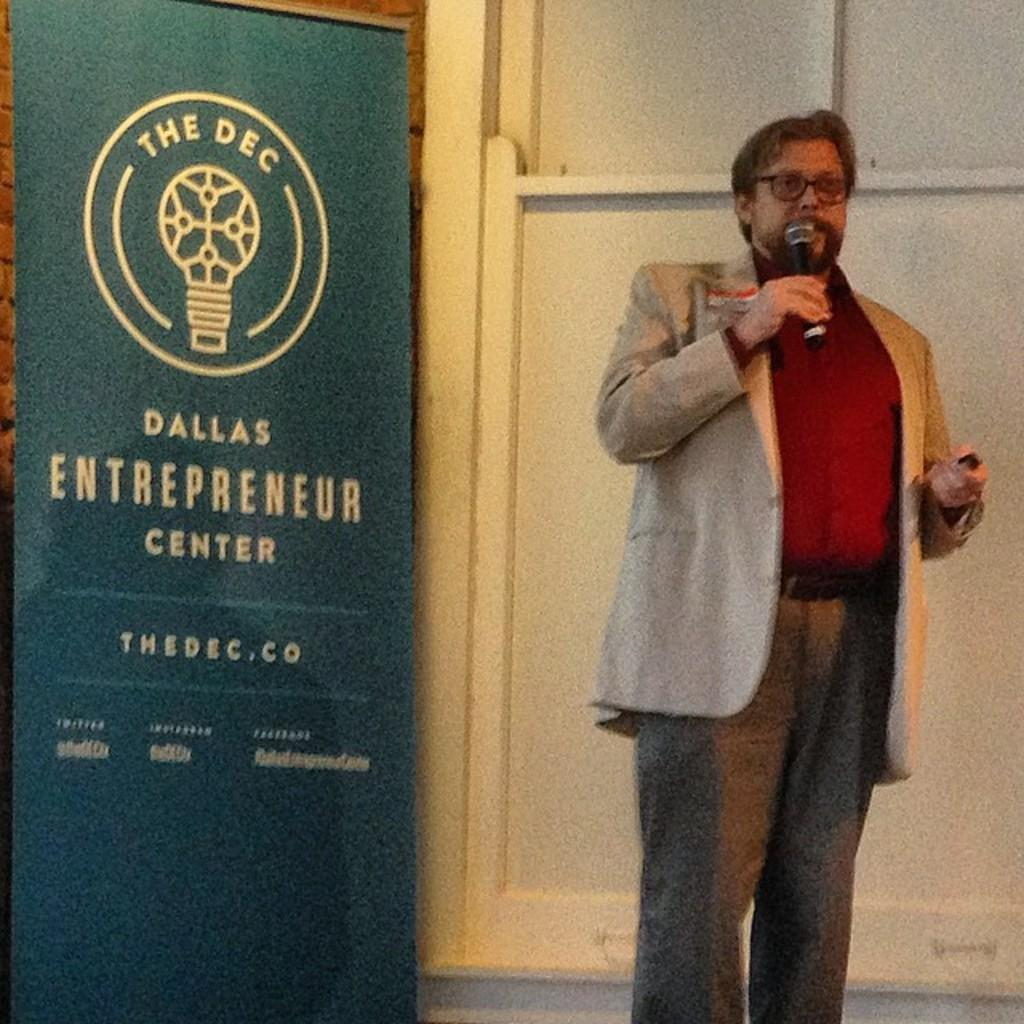<image>
Write a terse but informative summary of the picture. A man speaks in front of a banner for the Dallas Entrepreneur Center. 